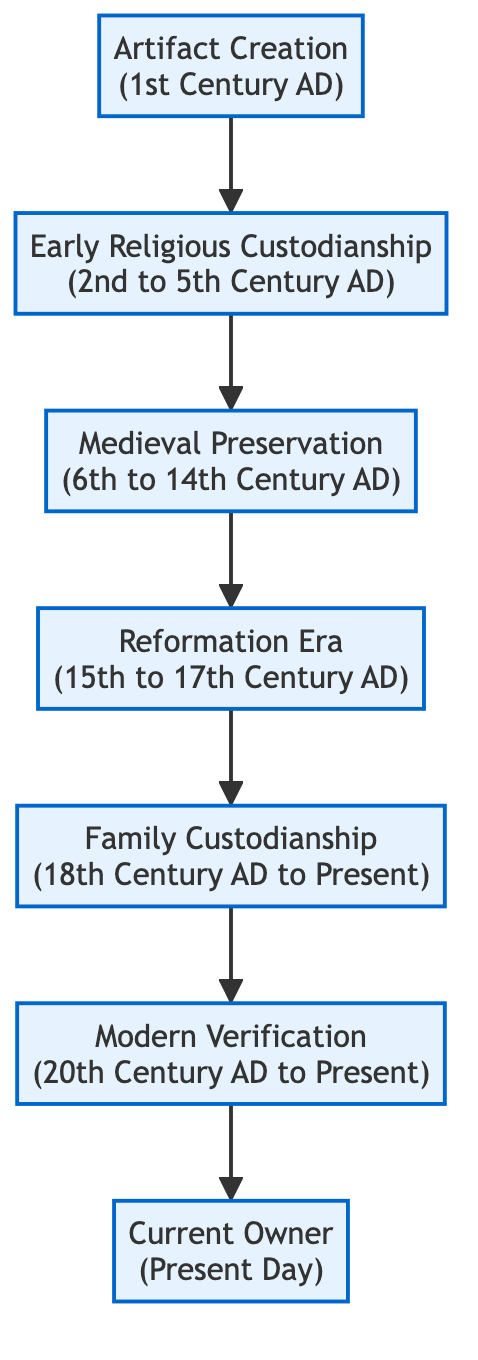What is the first node in the diagram? The first node represents the initial event in the flow chart, which is "Artifact Creation," marking the start of the lineage of religious artifacts.
Answer: Artifact Creation How many nodes are there in total? Counting each distinct event represented in the diagram, there are seven nodes that trace the lineage of the artifacts from creation to current ownership.
Answer: 7 What era does the "Family Custodianship" cover? The "Family Custodianship" node describes the time duration from the 18th Century AD to the present, indicating its long-term significance in the artifact's history.
Answer: 18th Century AD to Present Which parties are involved in the "Modern Verification"? The "Modern Verification" node lists specific organizations responsible for verifying artifacts, including the Smithsonian Institution and Vatican Archives, highlighting the expertise engaged in this process.
Answer: Smithsonian Institution, Vatican Archives What follows "Medieval Preservation" in the flow? The "Reformation Era" is directly linked to the "Medieval Preservation," indicating the transition in the care and context of religious artifacts during historical upheavals.
Answer: Reformation Era Why would artifacts be hidden during the Reformation Era? Artifacts were hidden due to religious upheavals, indicating a need for protection and preservation of their significance during a turbulent period in religious history.
Answer: Religious upheavals What is the relationship between the "Current Owner" and the "Artifact Creation"? The "Current Owner," a direct descendant of a religious figure, traces their ownership lineage back to the "Artifact Creation," showing an unbroken chain of custodianship over time.
Answer: Direct descendant In which era do we see the first expert verification of artifacts? The "Modern Verification" node, which indicates expert authentication, starts from the 20th Century AD to present, marking a distinct period for professional scrutiny of historical artifacts.
Answer: 20th Century AD to Present 